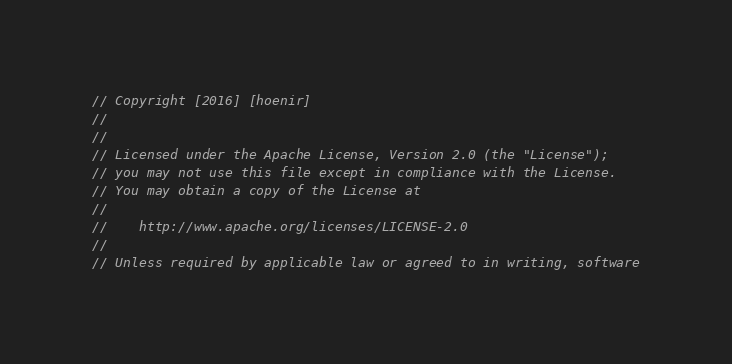Convert code to text. <code><loc_0><loc_0><loc_500><loc_500><_Go_>// Copyright [2016] [hoenir]
//
//
// Licensed under the Apache License, Version 2.0 (the "License");
// you may not use this file except in compliance with the License.
// You may obtain a copy of the License at
//
//    http://www.apache.org/licenses/LICENSE-2.0
//
// Unless required by applicable law or agreed to in writing, software</code> 